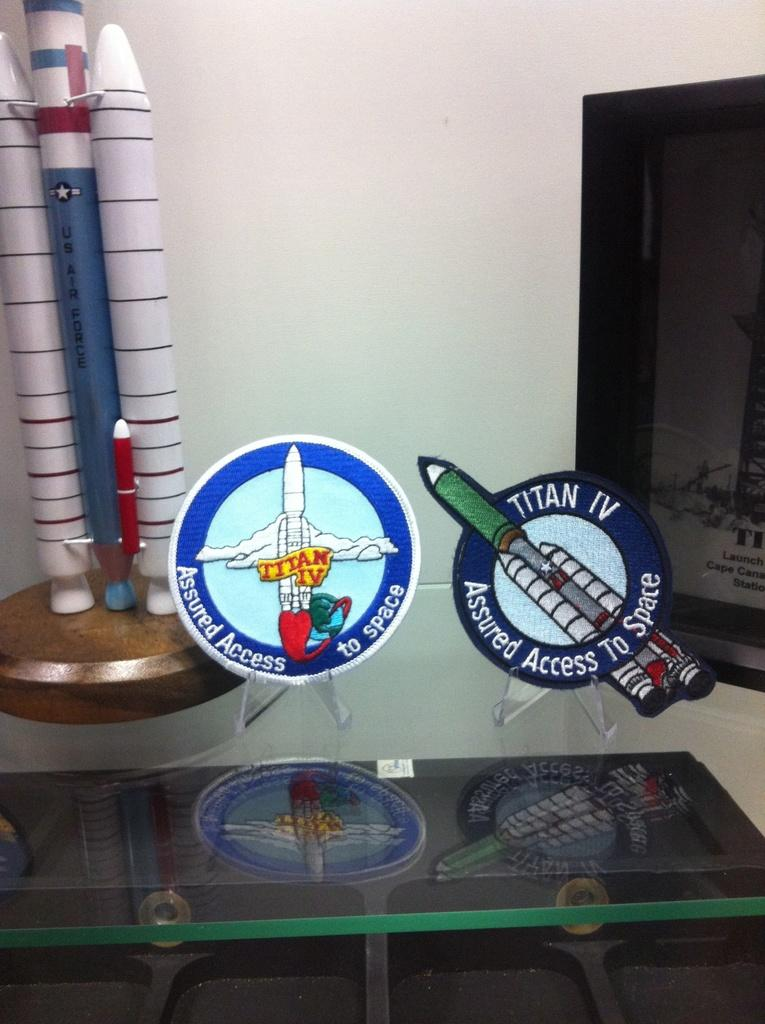Where was the image taken? The image was taken indoors. What can be seen in the background of the image? There is a wall in the background of the image. What is the main subject of the image? There are show pieces in the middle of the image. Can you describe the text in the image? There is a text on a glass table in the image. How many teeth can be seen on the seat in the image? There are no teeth or seats present in the image. What type of sugar is being used to sweeten the show pieces in the image? There is no sugar involved in the image; it features show pieces on display. 